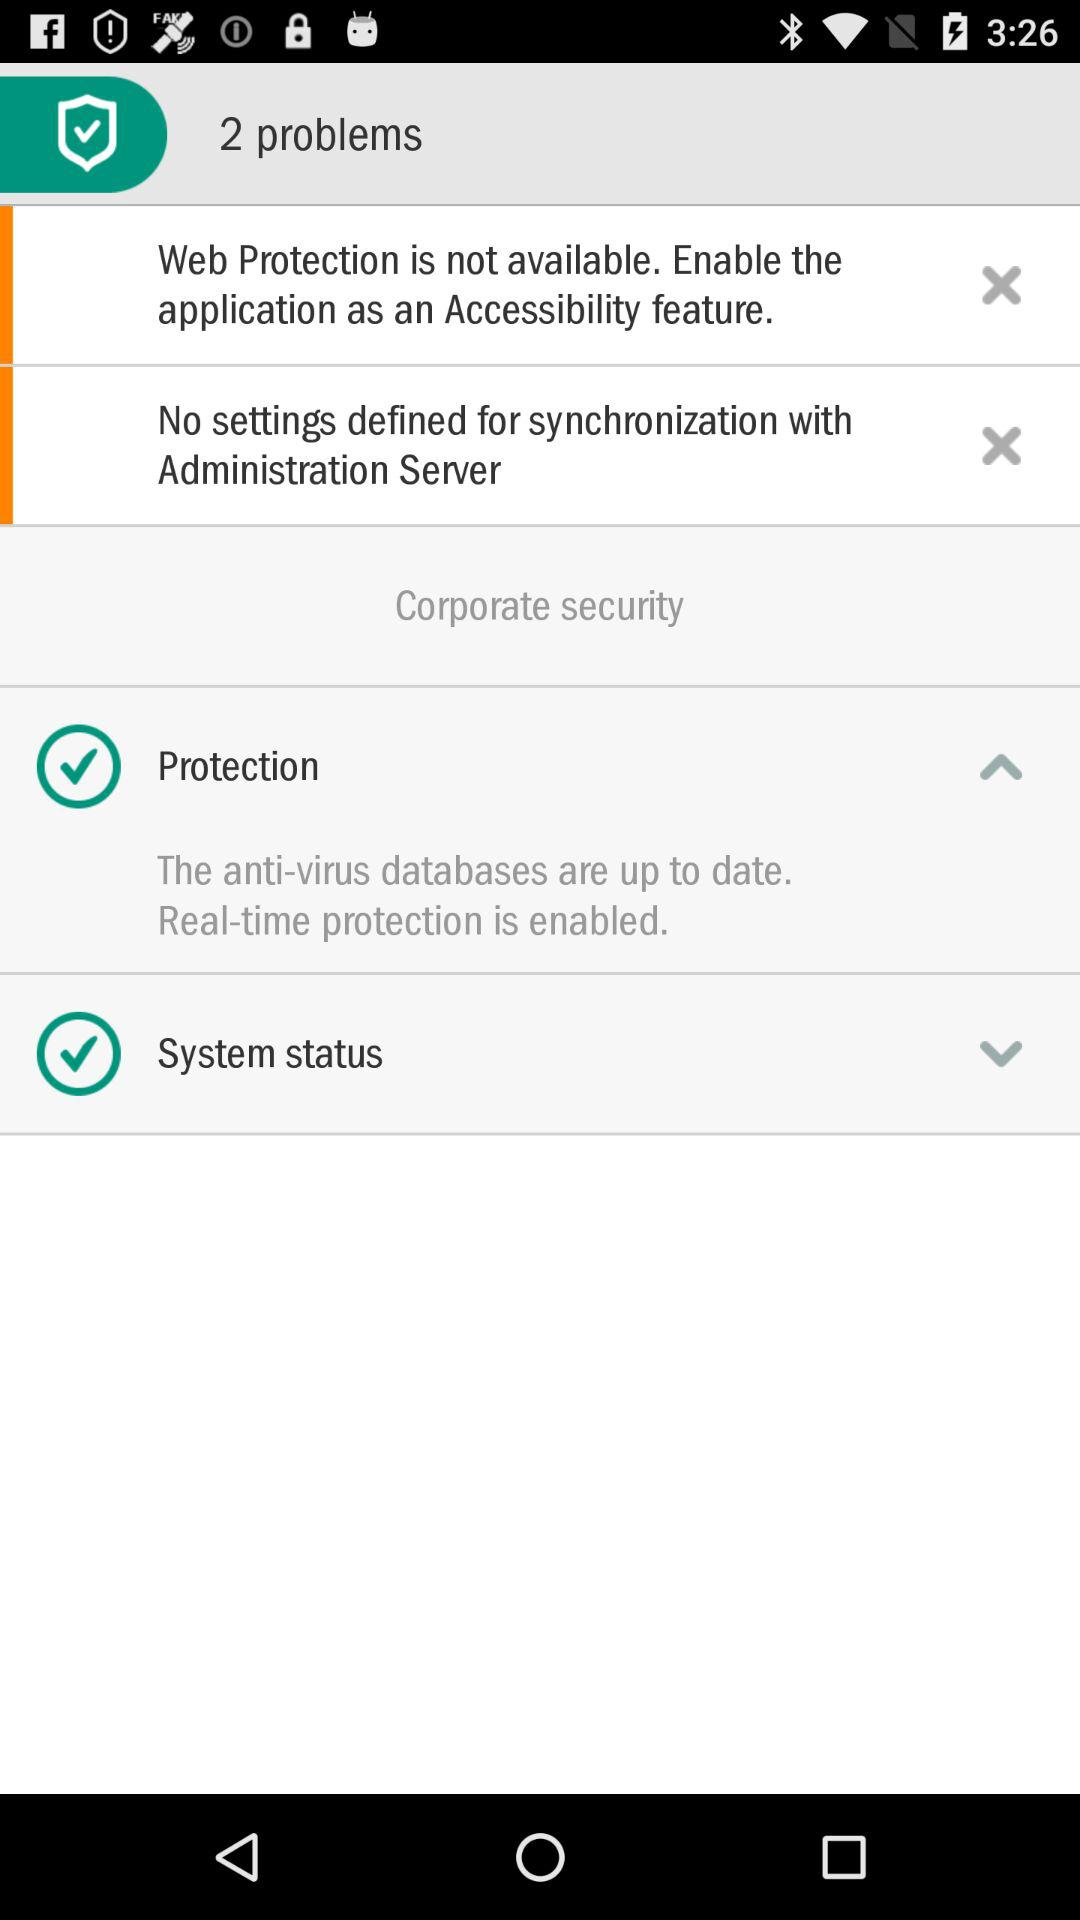What is protection shown?
When the provided information is insufficient, respond with <no answer>. <no answer> 